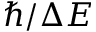Convert formula to latex. <formula><loc_0><loc_0><loc_500><loc_500>\hbar { / } \Delta E</formula> 